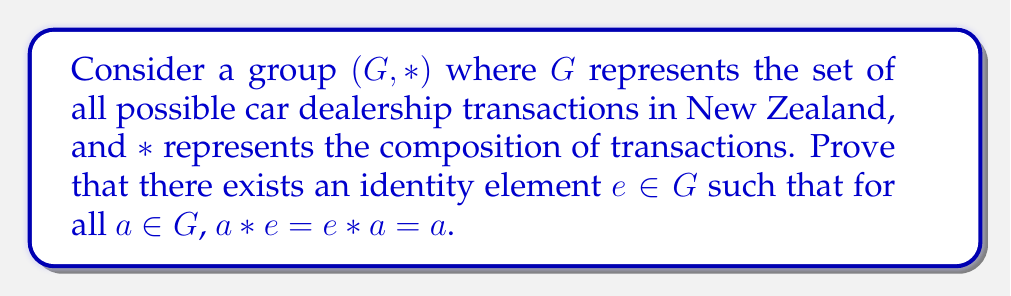Teach me how to tackle this problem. To prove the existence of an identity element in the group of car dealership transactions, we'll follow these steps:

1) First, let's define what the identity element would represent in this context. The identity element $e$ would be a transaction that, when composed with any other transaction, leaves that transaction unchanged.

2) In the context of a car dealership, this could be thought of as a "null transaction" where no cars are bought or sold.

3) To prove the existence of this identity element, we'll use the properties of a group:

   a) Closure: For all $a, b \in G$, $a * b \in G$
   b) Associativity: For all $a, b, c \in G$, $(a * b) * c = a * (b * c)$
   c) Identity: There exists an $e \in G$ such that for all $a \in G$, $a * e = e * a = a$
   d) Inverse: For each $a \in G$, there exists an element $a^{-1} \in G$ such that $a * a^{-1} = a^{-1} * a = e$

4) Let $a$ be any element in $G$. By the inverse property, there exists $a^{-1} \in G$.

5) Define $e = a * a^{-1}$. We will prove that this $e$ is the identity element.

6) For any $b \in G$:

   $e * b = (a * a^{-1}) * b$
   $= a * (a^{-1} * b)$  (by associativity)
   $= b$  (because $a^{-1} * b = a^{-1} * b$, and $a * (a^{-1} * b) = b$ by the inverse property)

7) Similarly:

   $b * e = b * (a * a^{-1})$
   $= (b * a) * a^{-1}$  (by associativity)
   $= b$  (because $b * a = b * a$, and $(b * a) * a^{-1} = b$ by the inverse property)

8) Therefore, $e * b = b * e = b$ for all $b \in G$, proving that $e$ is indeed the identity element.

In the context of car dealership transactions, this identity element $e$ represents a day where no cars are bought or sold, which when combined with any other day's transactions, doesn't change the overall result.
Answer: The identity element $e$ exists in the group of car dealership transactions and can be constructed as $e = a * a^{-1}$ for any $a \in G$, where $a^{-1}$ is the inverse of $a$. This identity element represents a null transaction that, when composed with any other transaction, leaves that transaction unchanged. 